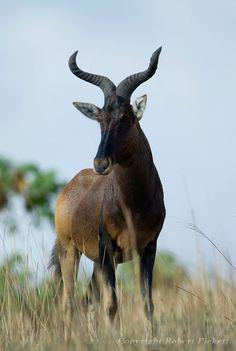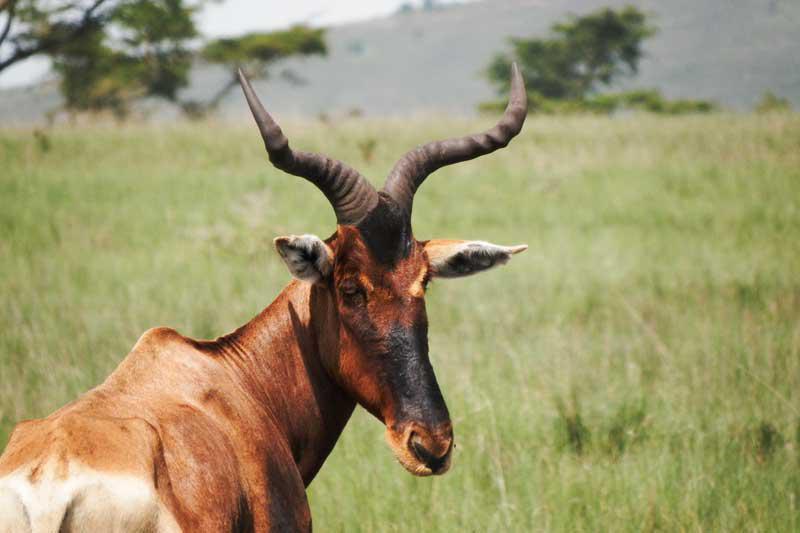The first image is the image on the left, the second image is the image on the right. Considering the images on both sides, is "One of the images features an animal facing left with it's head turned straight." valid? Answer yes or no. Yes. The first image is the image on the left, the second image is the image on the right. Examine the images to the left and right. Is the description "There is a whole heard of antelope in both of the images." accurate? Answer yes or no. No. 